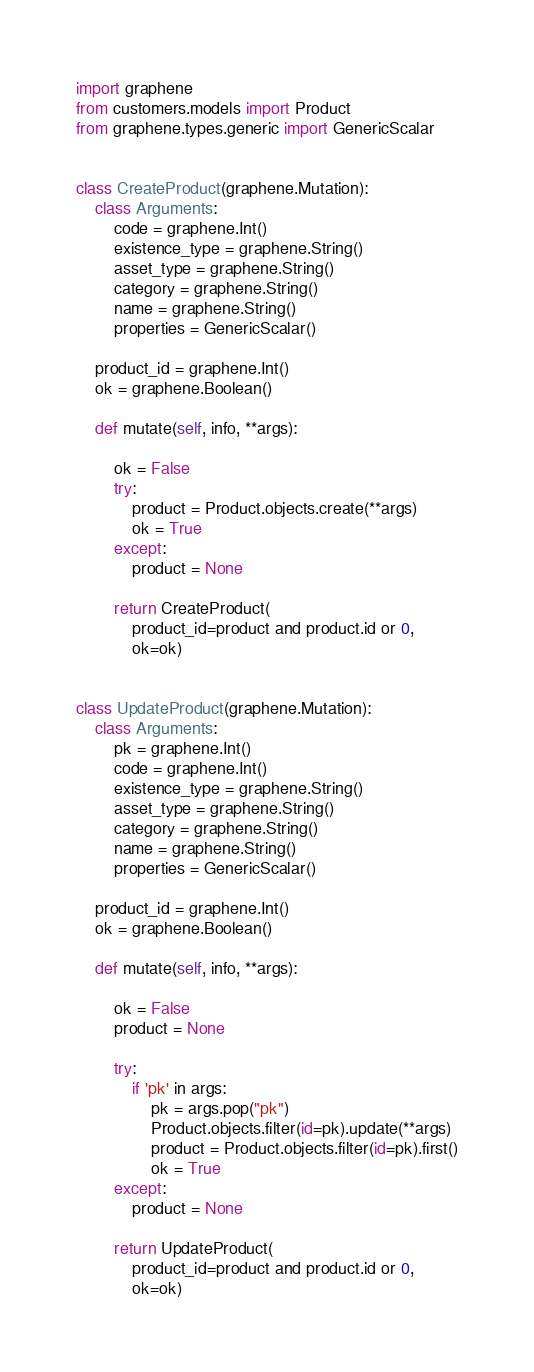Convert code to text. <code><loc_0><loc_0><loc_500><loc_500><_Python_>import graphene
from customers.models import Product
from graphene.types.generic import GenericScalar


class CreateProduct(graphene.Mutation):
    class Arguments:
        code = graphene.Int()
        existence_type = graphene.String()
        asset_type = graphene.String()
        category = graphene.String()
        name = graphene.String()
        properties = GenericScalar()

    product_id = graphene.Int()
    ok = graphene.Boolean()

    def mutate(self, info, **args):

        ok = False
        try:
            product = Product.objects.create(**args)
            ok = True
        except:
            product = None

        return CreateProduct(
            product_id=product and product.id or 0,
            ok=ok)


class UpdateProduct(graphene.Mutation):
    class Arguments:
        pk = graphene.Int()
        code = graphene.Int()
        existence_type = graphene.String()
        asset_type = graphene.String()
        category = graphene.String()
        name = graphene.String()
        properties = GenericScalar()

    product_id = graphene.Int()
    ok = graphene.Boolean()

    def mutate(self, info, **args):

        ok = False
        product = None

        try:
            if 'pk' in args:
                pk = args.pop("pk")
                Product.objects.filter(id=pk).update(**args)
                product = Product.objects.filter(id=pk).first()
                ok = True
        except:
            product = None

        return UpdateProduct(
            product_id=product and product.id or 0,
            ok=ok)
</code> 